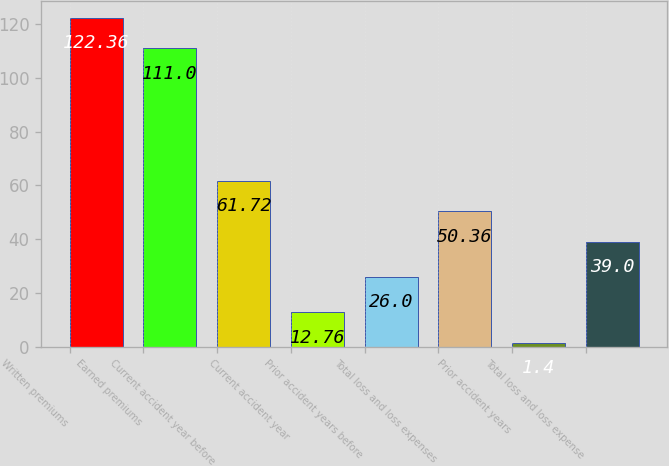Convert chart. <chart><loc_0><loc_0><loc_500><loc_500><bar_chart><fcel>Written premiums<fcel>Earned premiums<fcel>Current accident year before<fcel>Current accident year<fcel>Prior accident years before<fcel>Total loss and loss expenses<fcel>Prior accident years<fcel>Total loss and loss expense<nl><fcel>122.36<fcel>111<fcel>61.72<fcel>12.76<fcel>26<fcel>50.36<fcel>1.4<fcel>39<nl></chart> 